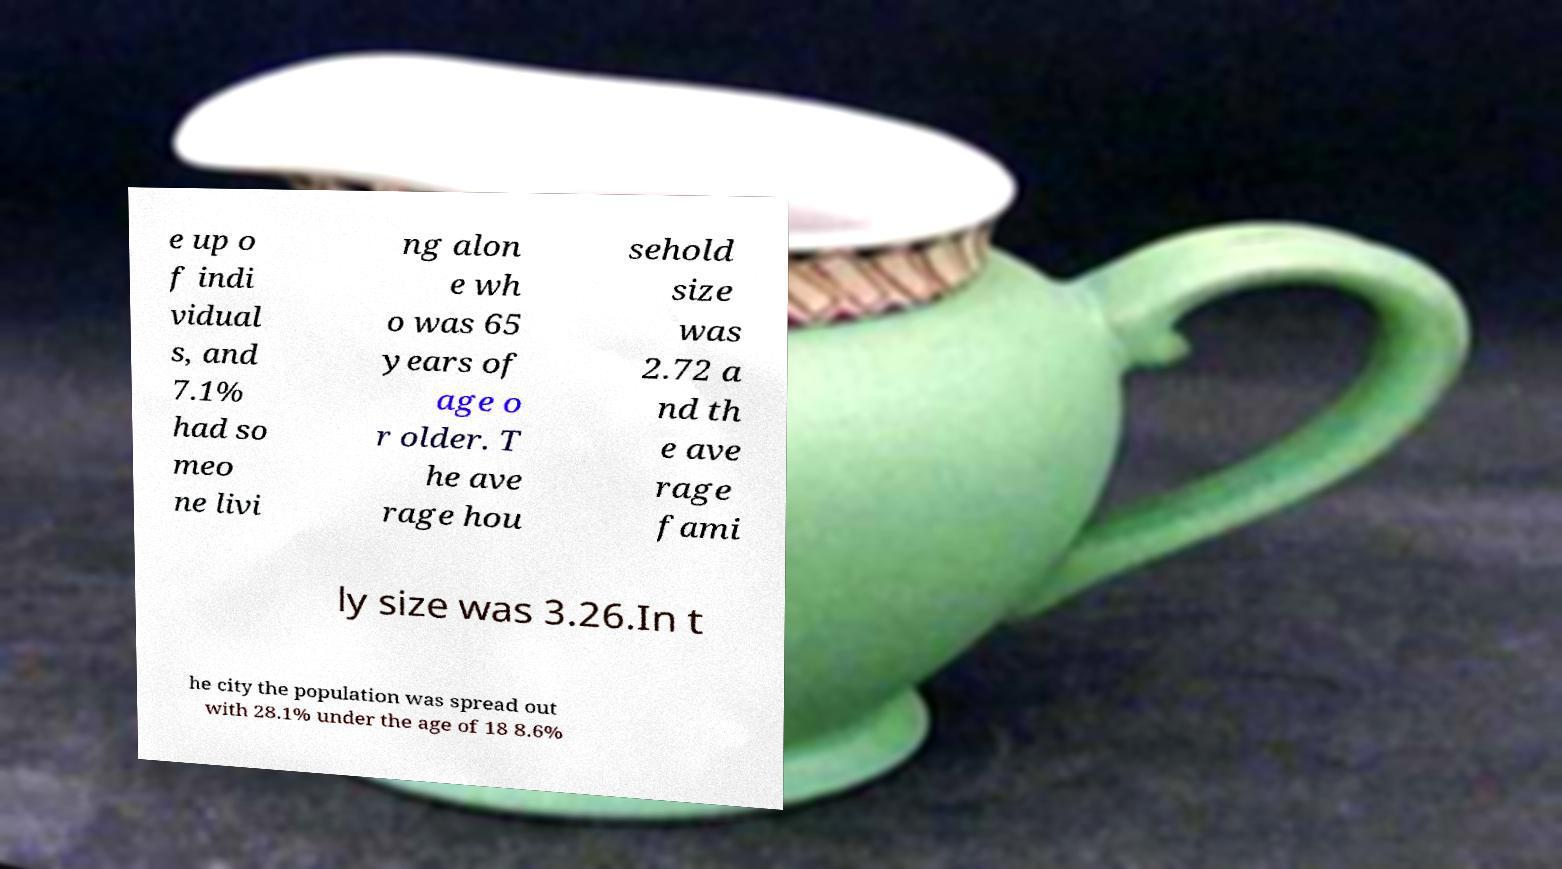Please identify and transcribe the text found in this image. e up o f indi vidual s, and 7.1% had so meo ne livi ng alon e wh o was 65 years of age o r older. T he ave rage hou sehold size was 2.72 a nd th e ave rage fami ly size was 3.26.In t he city the population was spread out with 28.1% under the age of 18 8.6% 